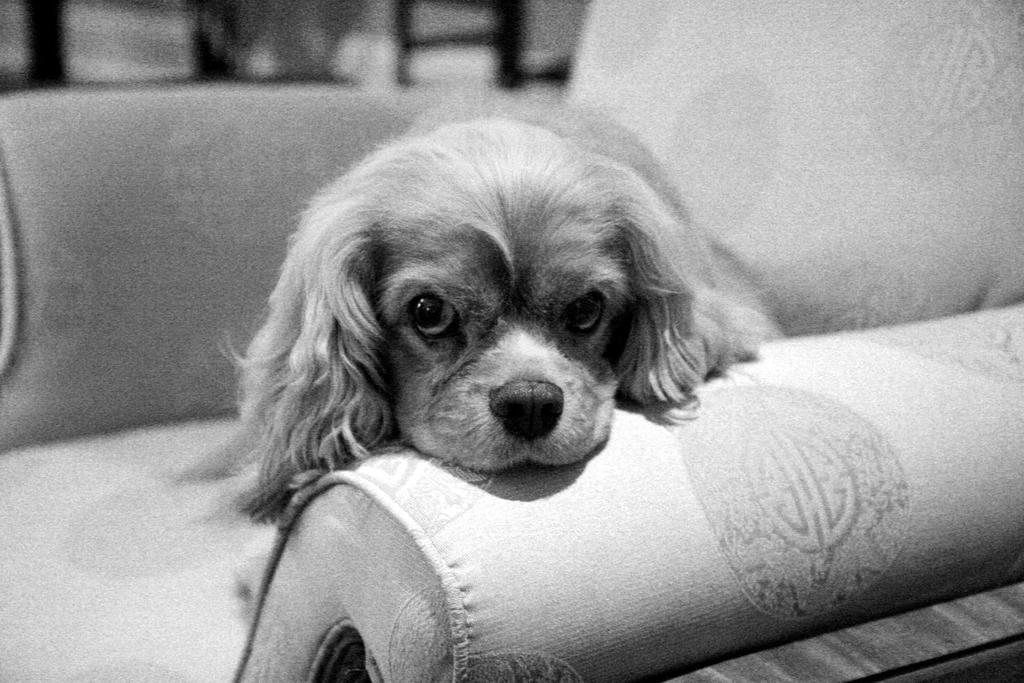Describe this image in one or two sentences. In this image I can see the dog on the couch. And this is a black and white image. 